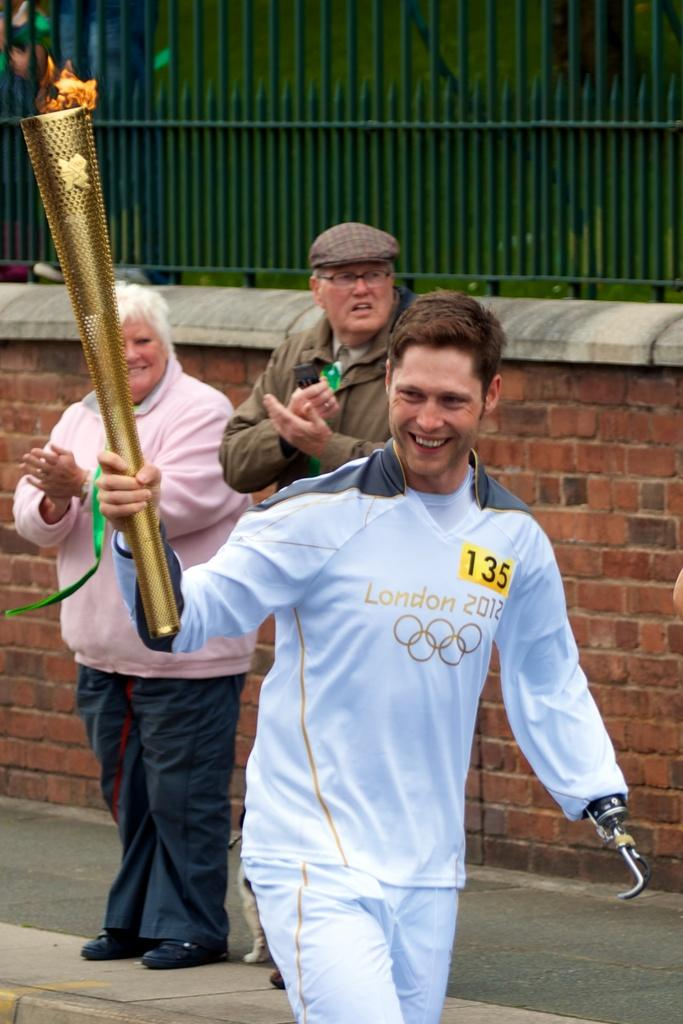<image>
Offer a succinct explanation of the picture presented. The person holding the torch is wearing the number 135. 